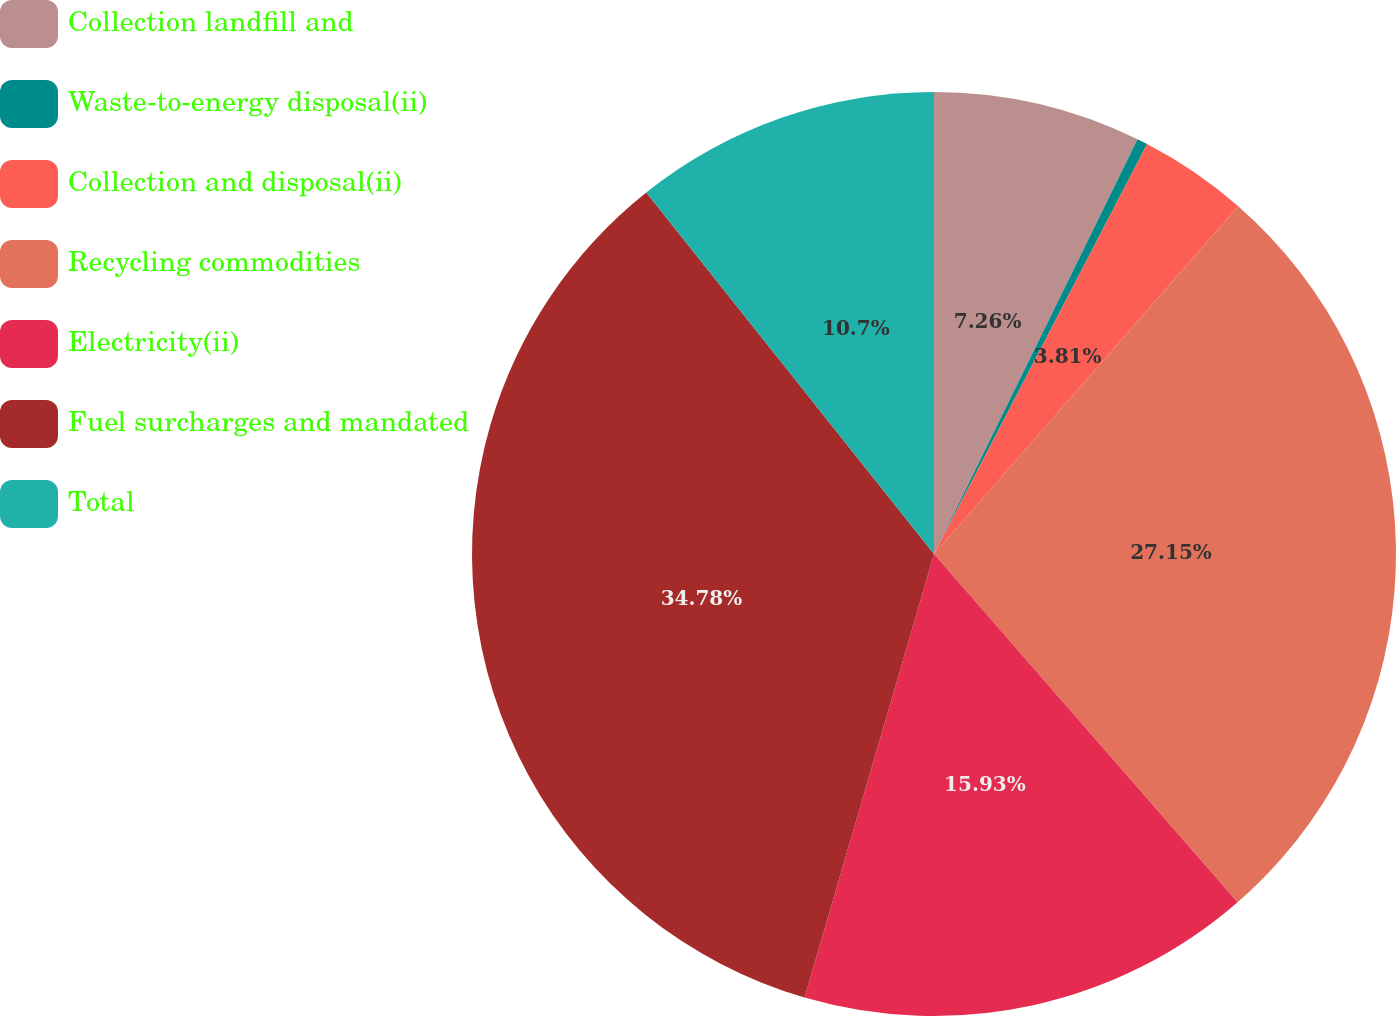<chart> <loc_0><loc_0><loc_500><loc_500><pie_chart><fcel>Collection landfill and<fcel>Waste-to-energy disposal(ii)<fcel>Collection and disposal(ii)<fcel>Recycling commodities<fcel>Electricity(ii)<fcel>Fuel surcharges and mandated<fcel>Total<nl><fcel>7.26%<fcel>0.37%<fcel>3.81%<fcel>27.15%<fcel>15.93%<fcel>34.78%<fcel>10.7%<nl></chart> 